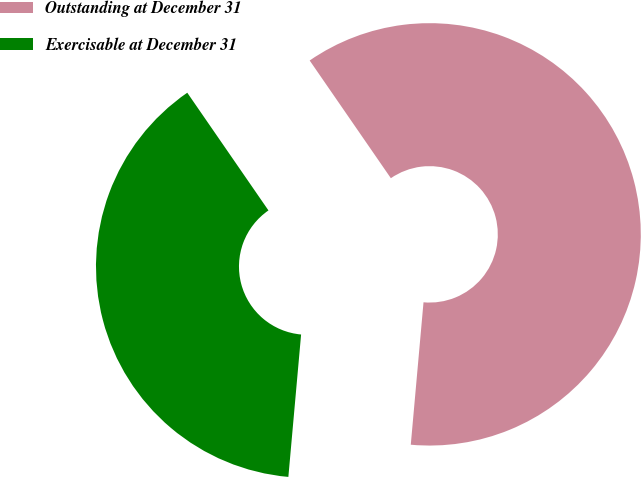Convert chart to OTSL. <chart><loc_0><loc_0><loc_500><loc_500><pie_chart><fcel>Outstanding at December 31<fcel>Exercisable at December 31<nl><fcel>61.03%<fcel>38.97%<nl></chart> 